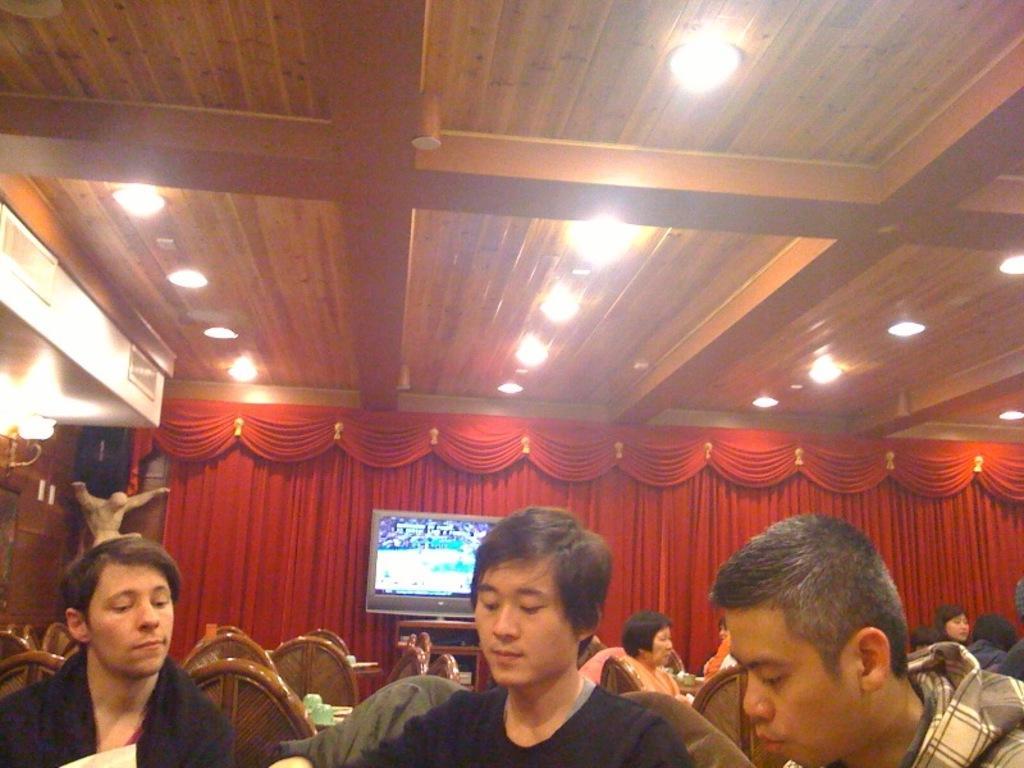In one or two sentences, can you explain what this image depicts? This picture shows the inner view of a building. There are some lights attached to the ceiling, some objects attached to the ceiling, some chairs, some tables, some lights attached to the wall, some objects attached to the wall, one object on the bottom right side of the image, one T. V with images on the wooden cupboard, some objects in the cupboard, some objects on the tables, some people sitting on the chairs and one red curtain with vintage in the background. 